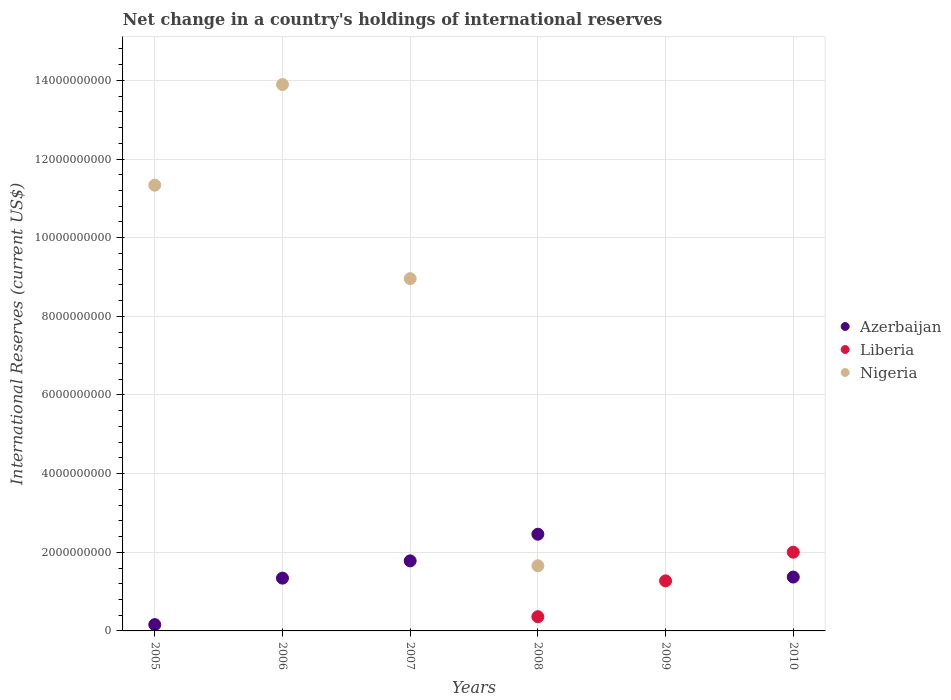How many different coloured dotlines are there?
Ensure brevity in your answer.  3. Is the number of dotlines equal to the number of legend labels?
Provide a short and direct response. No. What is the international reserves in Azerbaijan in 2006?
Offer a terse response. 1.34e+09. Across all years, what is the maximum international reserves in Nigeria?
Ensure brevity in your answer.  1.39e+1. In which year was the international reserves in Azerbaijan maximum?
Provide a short and direct response. 2008. What is the total international reserves in Azerbaijan in the graph?
Provide a short and direct response. 7.11e+09. What is the difference between the international reserves in Azerbaijan in 2007 and that in 2010?
Give a very brief answer. 4.11e+08. What is the difference between the international reserves in Azerbaijan in 2008 and the international reserves in Liberia in 2007?
Offer a terse response. 2.46e+09. What is the average international reserves in Nigeria per year?
Give a very brief answer. 5.97e+09. In the year 2007, what is the difference between the international reserves in Nigeria and international reserves in Azerbaijan?
Give a very brief answer. 7.18e+09. In how many years, is the international reserves in Azerbaijan greater than 10000000000 US$?
Keep it short and to the point. 0. What is the ratio of the international reserves in Nigeria in 2005 to that in 2007?
Your response must be concise. 1.27. Is the difference between the international reserves in Nigeria in 2006 and 2008 greater than the difference between the international reserves in Azerbaijan in 2006 and 2008?
Your answer should be very brief. Yes. What is the difference between the highest and the second highest international reserves in Liberia?
Ensure brevity in your answer.  7.30e+08. What is the difference between the highest and the lowest international reserves in Nigeria?
Your response must be concise. 1.39e+1. Does the international reserves in Liberia monotonically increase over the years?
Your answer should be compact. No. Is the international reserves in Azerbaijan strictly greater than the international reserves in Nigeria over the years?
Keep it short and to the point. No. How many dotlines are there?
Offer a terse response. 3. How many years are there in the graph?
Offer a terse response. 6. What is the difference between two consecutive major ticks on the Y-axis?
Offer a very short reply. 2.00e+09. Are the values on the major ticks of Y-axis written in scientific E-notation?
Provide a short and direct response. No. Does the graph contain any zero values?
Your response must be concise. Yes. Does the graph contain grids?
Keep it short and to the point. Yes. Where does the legend appear in the graph?
Offer a very short reply. Center right. How are the legend labels stacked?
Ensure brevity in your answer.  Vertical. What is the title of the graph?
Offer a very short reply. Net change in a country's holdings of international reserves. Does "Lao PDR" appear as one of the legend labels in the graph?
Your response must be concise. No. What is the label or title of the X-axis?
Give a very brief answer. Years. What is the label or title of the Y-axis?
Provide a succinct answer. International Reserves (current US$). What is the International Reserves (current US$) in Azerbaijan in 2005?
Provide a succinct answer. 1.61e+08. What is the International Reserves (current US$) of Liberia in 2005?
Provide a succinct answer. 0. What is the International Reserves (current US$) of Nigeria in 2005?
Offer a terse response. 1.13e+1. What is the International Reserves (current US$) of Azerbaijan in 2006?
Provide a short and direct response. 1.34e+09. What is the International Reserves (current US$) in Liberia in 2006?
Your answer should be very brief. 0. What is the International Reserves (current US$) in Nigeria in 2006?
Ensure brevity in your answer.  1.39e+1. What is the International Reserves (current US$) of Azerbaijan in 2007?
Offer a terse response. 1.78e+09. What is the International Reserves (current US$) of Nigeria in 2007?
Offer a terse response. 8.96e+09. What is the International Reserves (current US$) in Azerbaijan in 2008?
Your answer should be compact. 2.46e+09. What is the International Reserves (current US$) of Liberia in 2008?
Provide a short and direct response. 3.61e+08. What is the International Reserves (current US$) of Nigeria in 2008?
Give a very brief answer. 1.66e+09. What is the International Reserves (current US$) of Liberia in 2009?
Provide a short and direct response. 1.27e+09. What is the International Reserves (current US$) in Azerbaijan in 2010?
Provide a succinct answer. 1.37e+09. What is the International Reserves (current US$) of Liberia in 2010?
Offer a terse response. 2.00e+09. Across all years, what is the maximum International Reserves (current US$) in Azerbaijan?
Offer a terse response. 2.46e+09. Across all years, what is the maximum International Reserves (current US$) in Liberia?
Offer a terse response. 2.00e+09. Across all years, what is the maximum International Reserves (current US$) of Nigeria?
Keep it short and to the point. 1.39e+1. Across all years, what is the minimum International Reserves (current US$) of Azerbaijan?
Your response must be concise. 0. Across all years, what is the minimum International Reserves (current US$) of Liberia?
Give a very brief answer. 0. What is the total International Reserves (current US$) of Azerbaijan in the graph?
Ensure brevity in your answer.  7.11e+09. What is the total International Reserves (current US$) of Liberia in the graph?
Offer a terse response. 3.64e+09. What is the total International Reserves (current US$) in Nigeria in the graph?
Your answer should be very brief. 3.58e+1. What is the difference between the International Reserves (current US$) in Azerbaijan in 2005 and that in 2006?
Make the answer very short. -1.18e+09. What is the difference between the International Reserves (current US$) of Nigeria in 2005 and that in 2006?
Your response must be concise. -2.56e+09. What is the difference between the International Reserves (current US$) of Azerbaijan in 2005 and that in 2007?
Provide a short and direct response. -1.62e+09. What is the difference between the International Reserves (current US$) of Nigeria in 2005 and that in 2007?
Your answer should be compact. 2.38e+09. What is the difference between the International Reserves (current US$) in Azerbaijan in 2005 and that in 2008?
Your response must be concise. -2.30e+09. What is the difference between the International Reserves (current US$) of Nigeria in 2005 and that in 2008?
Your response must be concise. 9.68e+09. What is the difference between the International Reserves (current US$) of Azerbaijan in 2005 and that in 2010?
Your response must be concise. -1.21e+09. What is the difference between the International Reserves (current US$) in Azerbaijan in 2006 and that in 2007?
Provide a short and direct response. -4.39e+08. What is the difference between the International Reserves (current US$) in Nigeria in 2006 and that in 2007?
Make the answer very short. 4.94e+09. What is the difference between the International Reserves (current US$) in Azerbaijan in 2006 and that in 2008?
Ensure brevity in your answer.  -1.12e+09. What is the difference between the International Reserves (current US$) of Nigeria in 2006 and that in 2008?
Your answer should be very brief. 1.22e+1. What is the difference between the International Reserves (current US$) of Azerbaijan in 2006 and that in 2010?
Your response must be concise. -2.74e+07. What is the difference between the International Reserves (current US$) in Azerbaijan in 2007 and that in 2008?
Your answer should be very brief. -6.78e+08. What is the difference between the International Reserves (current US$) of Nigeria in 2007 and that in 2008?
Provide a succinct answer. 7.30e+09. What is the difference between the International Reserves (current US$) in Azerbaijan in 2007 and that in 2010?
Provide a succinct answer. 4.11e+08. What is the difference between the International Reserves (current US$) in Liberia in 2008 and that in 2009?
Offer a very short reply. -9.12e+08. What is the difference between the International Reserves (current US$) of Azerbaijan in 2008 and that in 2010?
Make the answer very short. 1.09e+09. What is the difference between the International Reserves (current US$) in Liberia in 2008 and that in 2010?
Your answer should be very brief. -1.64e+09. What is the difference between the International Reserves (current US$) of Liberia in 2009 and that in 2010?
Provide a succinct answer. -7.30e+08. What is the difference between the International Reserves (current US$) of Azerbaijan in 2005 and the International Reserves (current US$) of Nigeria in 2006?
Your answer should be very brief. -1.37e+1. What is the difference between the International Reserves (current US$) of Azerbaijan in 2005 and the International Reserves (current US$) of Nigeria in 2007?
Your answer should be compact. -8.80e+09. What is the difference between the International Reserves (current US$) of Azerbaijan in 2005 and the International Reserves (current US$) of Liberia in 2008?
Your answer should be very brief. -2.01e+08. What is the difference between the International Reserves (current US$) of Azerbaijan in 2005 and the International Reserves (current US$) of Nigeria in 2008?
Offer a terse response. -1.50e+09. What is the difference between the International Reserves (current US$) of Azerbaijan in 2005 and the International Reserves (current US$) of Liberia in 2009?
Ensure brevity in your answer.  -1.11e+09. What is the difference between the International Reserves (current US$) in Azerbaijan in 2005 and the International Reserves (current US$) in Liberia in 2010?
Provide a short and direct response. -1.84e+09. What is the difference between the International Reserves (current US$) of Azerbaijan in 2006 and the International Reserves (current US$) of Nigeria in 2007?
Keep it short and to the point. -7.62e+09. What is the difference between the International Reserves (current US$) in Azerbaijan in 2006 and the International Reserves (current US$) in Liberia in 2008?
Provide a succinct answer. 9.81e+08. What is the difference between the International Reserves (current US$) of Azerbaijan in 2006 and the International Reserves (current US$) of Nigeria in 2008?
Provide a short and direct response. -3.15e+08. What is the difference between the International Reserves (current US$) in Azerbaijan in 2006 and the International Reserves (current US$) in Liberia in 2009?
Your answer should be compact. 6.96e+07. What is the difference between the International Reserves (current US$) in Azerbaijan in 2006 and the International Reserves (current US$) in Liberia in 2010?
Offer a very short reply. -6.60e+08. What is the difference between the International Reserves (current US$) in Azerbaijan in 2007 and the International Reserves (current US$) in Liberia in 2008?
Offer a terse response. 1.42e+09. What is the difference between the International Reserves (current US$) of Azerbaijan in 2007 and the International Reserves (current US$) of Nigeria in 2008?
Ensure brevity in your answer.  1.24e+08. What is the difference between the International Reserves (current US$) of Azerbaijan in 2007 and the International Reserves (current US$) of Liberia in 2009?
Your response must be concise. 5.08e+08. What is the difference between the International Reserves (current US$) of Azerbaijan in 2007 and the International Reserves (current US$) of Liberia in 2010?
Your answer should be compact. -2.21e+08. What is the difference between the International Reserves (current US$) of Azerbaijan in 2008 and the International Reserves (current US$) of Liberia in 2009?
Your response must be concise. 1.19e+09. What is the difference between the International Reserves (current US$) of Azerbaijan in 2008 and the International Reserves (current US$) of Liberia in 2010?
Offer a very short reply. 4.57e+08. What is the average International Reserves (current US$) in Azerbaijan per year?
Offer a terse response. 1.19e+09. What is the average International Reserves (current US$) of Liberia per year?
Ensure brevity in your answer.  6.06e+08. What is the average International Reserves (current US$) of Nigeria per year?
Ensure brevity in your answer.  5.97e+09. In the year 2005, what is the difference between the International Reserves (current US$) in Azerbaijan and International Reserves (current US$) in Nigeria?
Offer a terse response. -1.12e+1. In the year 2006, what is the difference between the International Reserves (current US$) of Azerbaijan and International Reserves (current US$) of Nigeria?
Give a very brief answer. -1.26e+1. In the year 2007, what is the difference between the International Reserves (current US$) in Azerbaijan and International Reserves (current US$) in Nigeria?
Your response must be concise. -7.18e+09. In the year 2008, what is the difference between the International Reserves (current US$) of Azerbaijan and International Reserves (current US$) of Liberia?
Your response must be concise. 2.10e+09. In the year 2008, what is the difference between the International Reserves (current US$) of Azerbaijan and International Reserves (current US$) of Nigeria?
Give a very brief answer. 8.02e+08. In the year 2008, what is the difference between the International Reserves (current US$) of Liberia and International Reserves (current US$) of Nigeria?
Ensure brevity in your answer.  -1.30e+09. In the year 2010, what is the difference between the International Reserves (current US$) of Azerbaijan and International Reserves (current US$) of Liberia?
Your answer should be compact. -6.32e+08. What is the ratio of the International Reserves (current US$) in Azerbaijan in 2005 to that in 2006?
Your answer should be compact. 0.12. What is the ratio of the International Reserves (current US$) in Nigeria in 2005 to that in 2006?
Keep it short and to the point. 0.82. What is the ratio of the International Reserves (current US$) of Azerbaijan in 2005 to that in 2007?
Give a very brief answer. 0.09. What is the ratio of the International Reserves (current US$) of Nigeria in 2005 to that in 2007?
Provide a succinct answer. 1.27. What is the ratio of the International Reserves (current US$) in Azerbaijan in 2005 to that in 2008?
Offer a very short reply. 0.07. What is the ratio of the International Reserves (current US$) in Nigeria in 2005 to that in 2008?
Your response must be concise. 6.84. What is the ratio of the International Reserves (current US$) of Azerbaijan in 2005 to that in 2010?
Ensure brevity in your answer.  0.12. What is the ratio of the International Reserves (current US$) in Azerbaijan in 2006 to that in 2007?
Provide a short and direct response. 0.75. What is the ratio of the International Reserves (current US$) of Nigeria in 2006 to that in 2007?
Your answer should be compact. 1.55. What is the ratio of the International Reserves (current US$) in Azerbaijan in 2006 to that in 2008?
Offer a terse response. 0.55. What is the ratio of the International Reserves (current US$) of Nigeria in 2006 to that in 2008?
Your answer should be very brief. 8.38. What is the ratio of the International Reserves (current US$) of Azerbaijan in 2006 to that in 2010?
Give a very brief answer. 0.98. What is the ratio of the International Reserves (current US$) in Azerbaijan in 2007 to that in 2008?
Provide a succinct answer. 0.72. What is the ratio of the International Reserves (current US$) of Nigeria in 2007 to that in 2008?
Your response must be concise. 5.41. What is the ratio of the International Reserves (current US$) of Azerbaijan in 2007 to that in 2010?
Your response must be concise. 1.3. What is the ratio of the International Reserves (current US$) in Liberia in 2008 to that in 2009?
Provide a short and direct response. 0.28. What is the ratio of the International Reserves (current US$) in Azerbaijan in 2008 to that in 2010?
Provide a short and direct response. 1.8. What is the ratio of the International Reserves (current US$) of Liberia in 2008 to that in 2010?
Offer a terse response. 0.18. What is the ratio of the International Reserves (current US$) of Liberia in 2009 to that in 2010?
Make the answer very short. 0.64. What is the difference between the highest and the second highest International Reserves (current US$) in Azerbaijan?
Make the answer very short. 6.78e+08. What is the difference between the highest and the second highest International Reserves (current US$) in Liberia?
Your response must be concise. 7.30e+08. What is the difference between the highest and the second highest International Reserves (current US$) in Nigeria?
Give a very brief answer. 2.56e+09. What is the difference between the highest and the lowest International Reserves (current US$) in Azerbaijan?
Your answer should be very brief. 2.46e+09. What is the difference between the highest and the lowest International Reserves (current US$) in Liberia?
Offer a very short reply. 2.00e+09. What is the difference between the highest and the lowest International Reserves (current US$) of Nigeria?
Provide a short and direct response. 1.39e+1. 